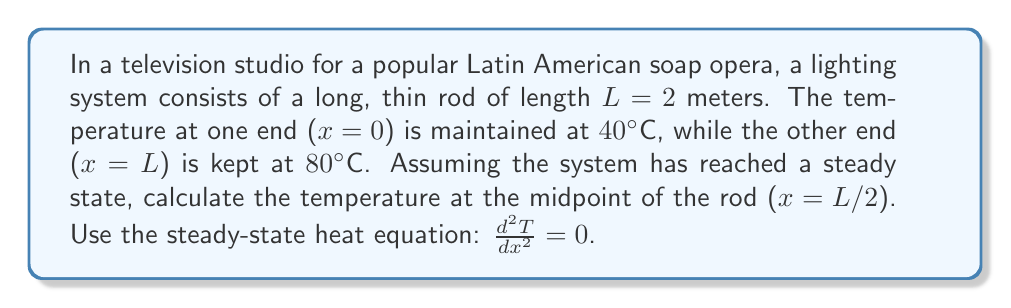Can you solve this math problem? To solve this problem, we'll follow these steps:

1) The steady-state heat equation is $\frac{d^2T}{dx^2} = 0$

2) Integrating twice, we get:
   $\frac{dT}{dx} = C_1$
   $T(x) = C_1x + C_2$

3) We now use the boundary conditions to find $C_1$ and $C_2$:
   At $x=0$, $T(0) = 40°C$: $40 = C_2$
   At $x=L=2$, $T(2) = 80°C$: $80 = 2C_1 + 40$

4) Solving for $C_1$:
   $80 - 40 = 2C_1$
   $C_1 = 20$

5) Therefore, the temperature distribution is:
   $T(x) = 20x + 40$

6) To find the temperature at the midpoint, we substitute $x = L/2 = 1$:
   $T(1) = 20(1) + 40 = 60°C$
Answer: $60°C$ 